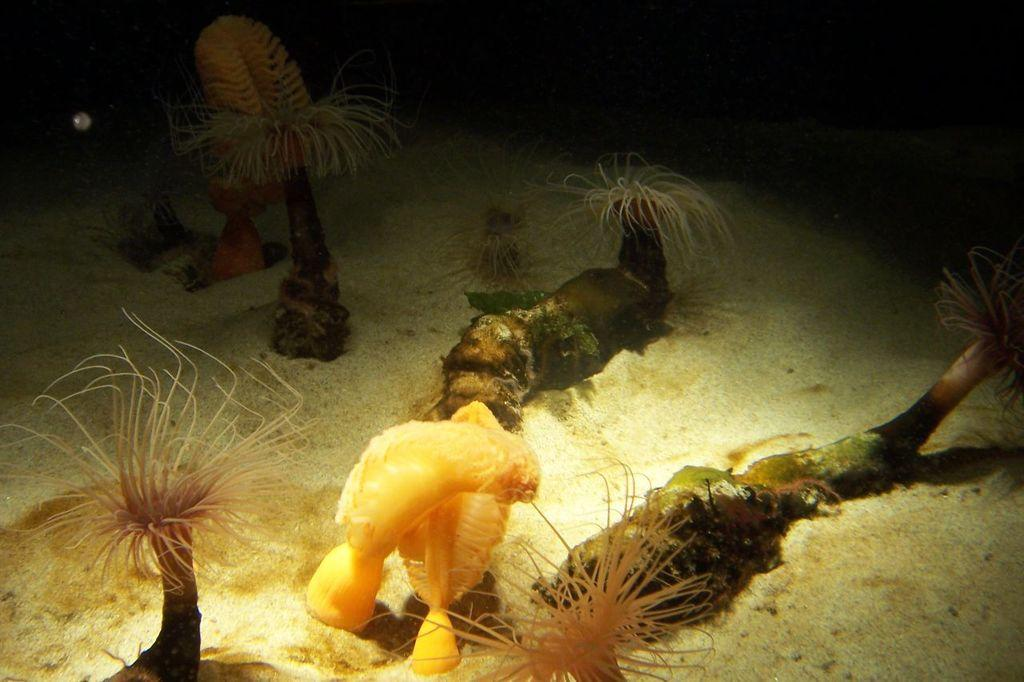What type of living organisms can be seen in the image? Plants can be seen in the image. What else is present on the ground in the image? There are objects on the ground in the image. What can be observed about the background of the image? The background of the image is dark. What type of debt is being discussed in the image? There is no mention of debt in the image; it features plants and objects on the ground. Can you see any fish in the image? There are no fish present in the image. 